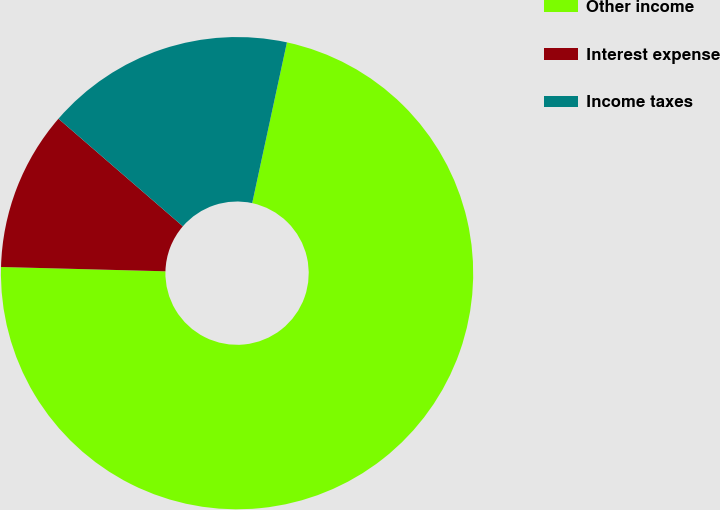<chart> <loc_0><loc_0><loc_500><loc_500><pie_chart><fcel>Other income<fcel>Interest expense<fcel>Income taxes<nl><fcel>72.03%<fcel>10.93%<fcel>17.04%<nl></chart> 